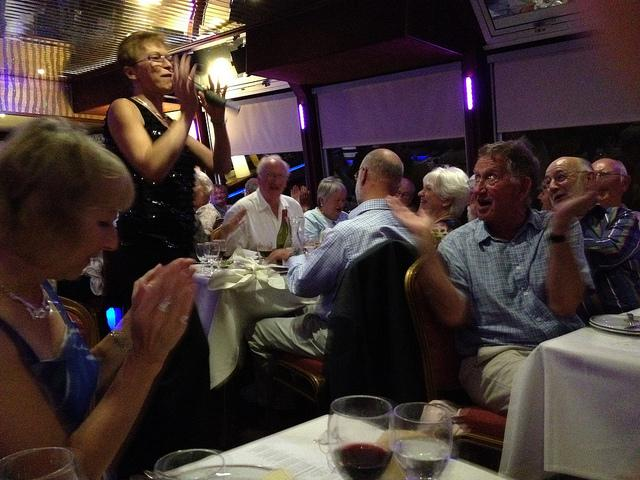What is the entertainment tonight for the people eating dinner?

Choices:
A) acrobats
B) movie
C) live singing
D) magic show live singing 